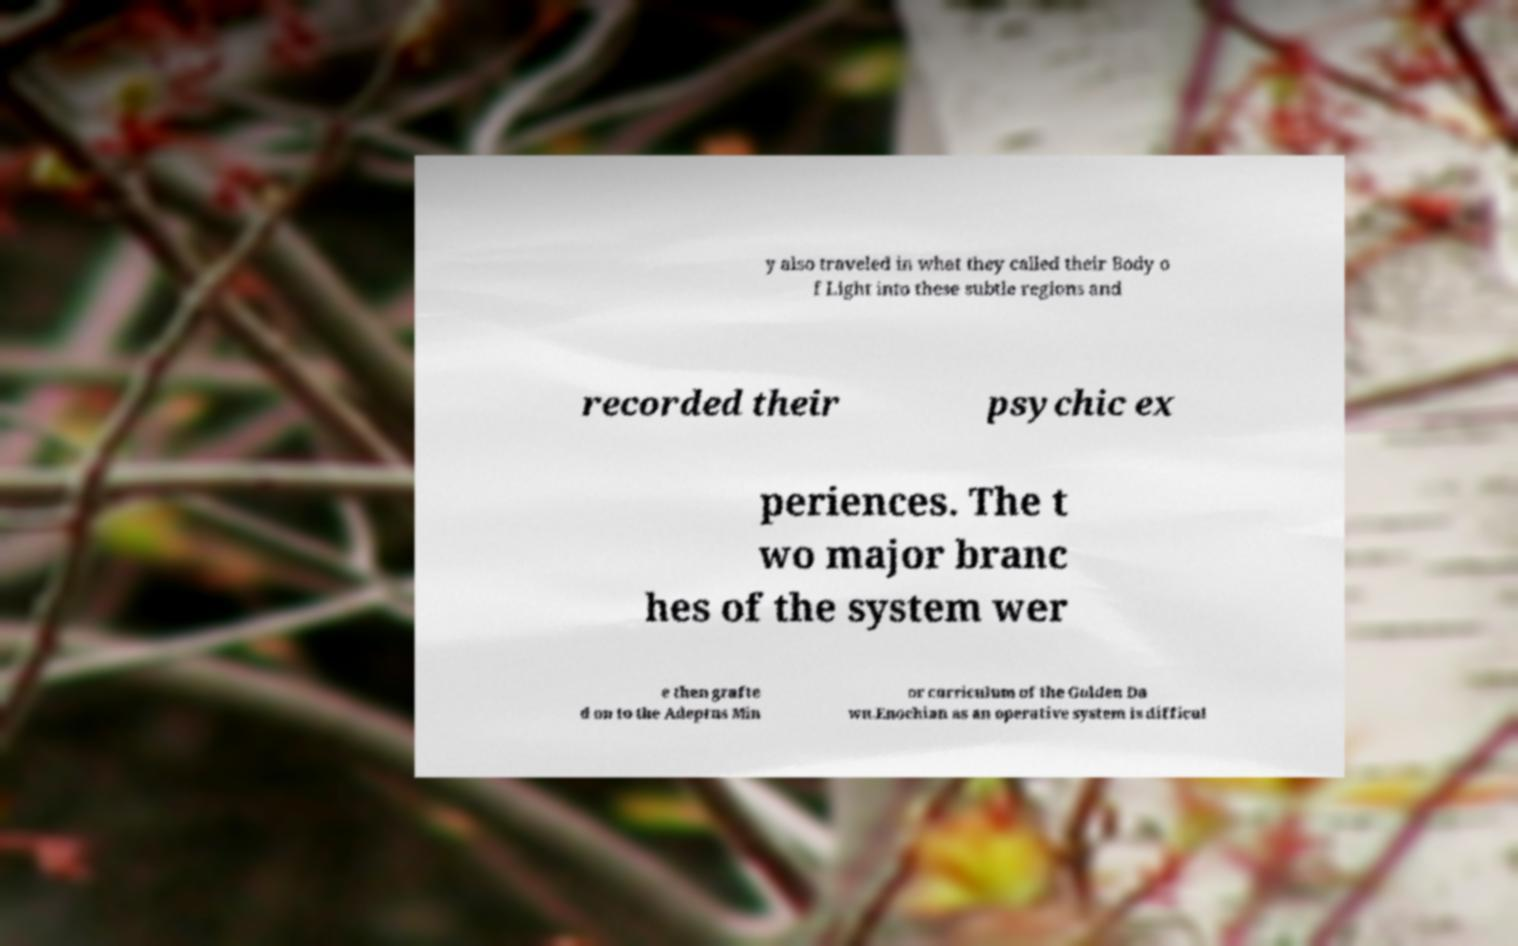Could you extract and type out the text from this image? y also traveled in what they called their Body o f Light into these subtle regions and recorded their psychic ex periences. The t wo major branc hes of the system wer e then grafte d on to the Adeptus Min or curriculum of the Golden Da wn.Enochian as an operative system is difficul 